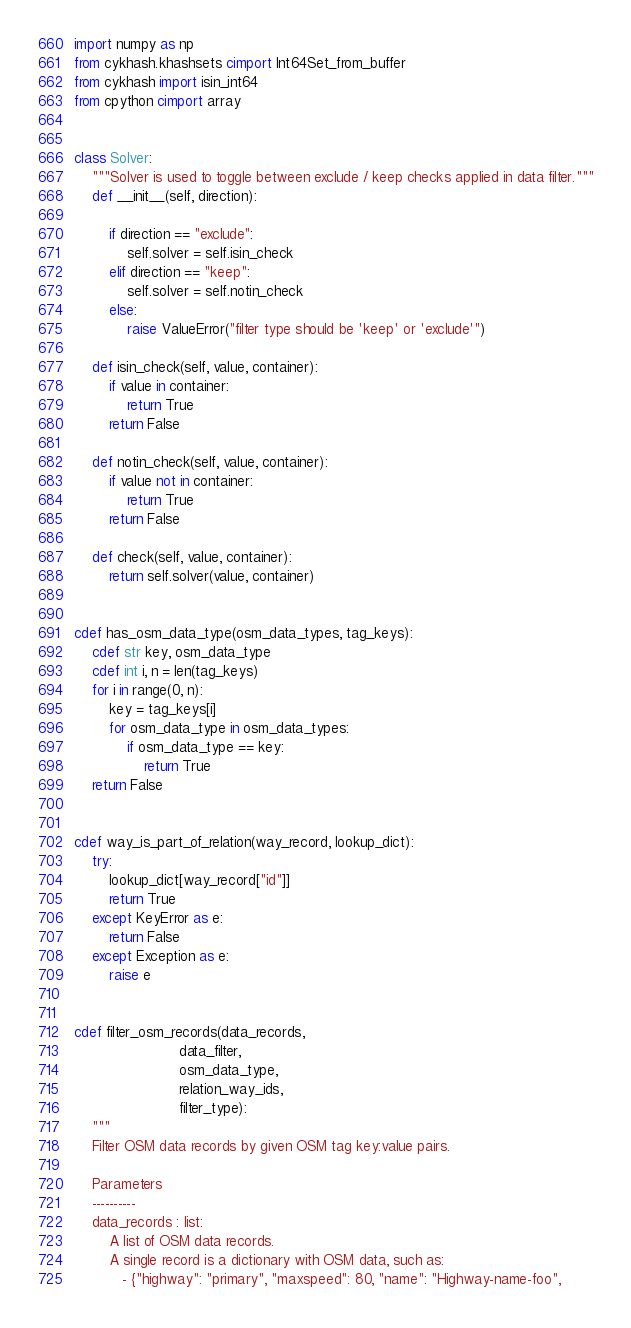Convert code to text. <code><loc_0><loc_0><loc_500><loc_500><_Cython_>import numpy as np
from cykhash.khashsets cimport Int64Set_from_buffer
from cykhash import isin_int64
from cpython cimport array


class Solver:
    """Solver is used to toggle between exclude / keep checks applied in data filter."""
    def __init__(self, direction):

        if direction == "exclude":
            self.solver = self.isin_check
        elif direction == "keep":
            self.solver = self.notin_check
        else:
            raise ValueError("filter type should be 'keep' or 'exclude'")

    def isin_check(self, value, container):
        if value in container:
            return True
        return False

    def notin_check(self, value, container):
        if value not in container:
            return True
        return False

    def check(self, value, container):
        return self.solver(value, container)


cdef has_osm_data_type(osm_data_types, tag_keys):
    cdef str key, osm_data_type
    cdef int i, n = len(tag_keys)
    for i in range(0, n):
        key = tag_keys[i]
        for osm_data_type in osm_data_types:
            if osm_data_type == key:
                return True
    return False


cdef way_is_part_of_relation(way_record, lookup_dict):
    try:
        lookup_dict[way_record["id"]]
        return True
    except KeyError as e:
        return False
    except Exception as e:
        raise e


cdef filter_osm_records(data_records,
                        data_filter,
                        osm_data_type,
                        relation_way_ids,
                        filter_type):
    """
    Filter OSM data records by given OSM tag key:value pairs.
    
    Parameters
    ----------
    data_records : list:
        A list of OSM data records. 
        A single record is a dictionary with OSM data, such as: 
           - {"highway": "primary", "maxspeed": 80, "name": "Highway-name-foo", </code> 